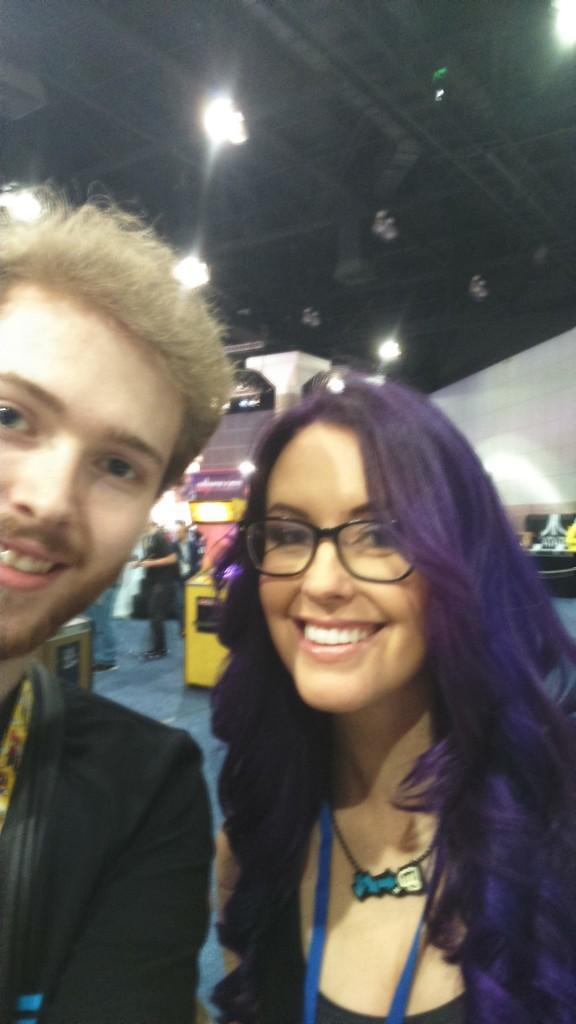How would you summarize this image in a sentence or two? In this picture I can see there is a man and a woman standing and they are smiling. There are lights attached to the ceiling. 